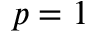<formula> <loc_0><loc_0><loc_500><loc_500>p = 1</formula> 